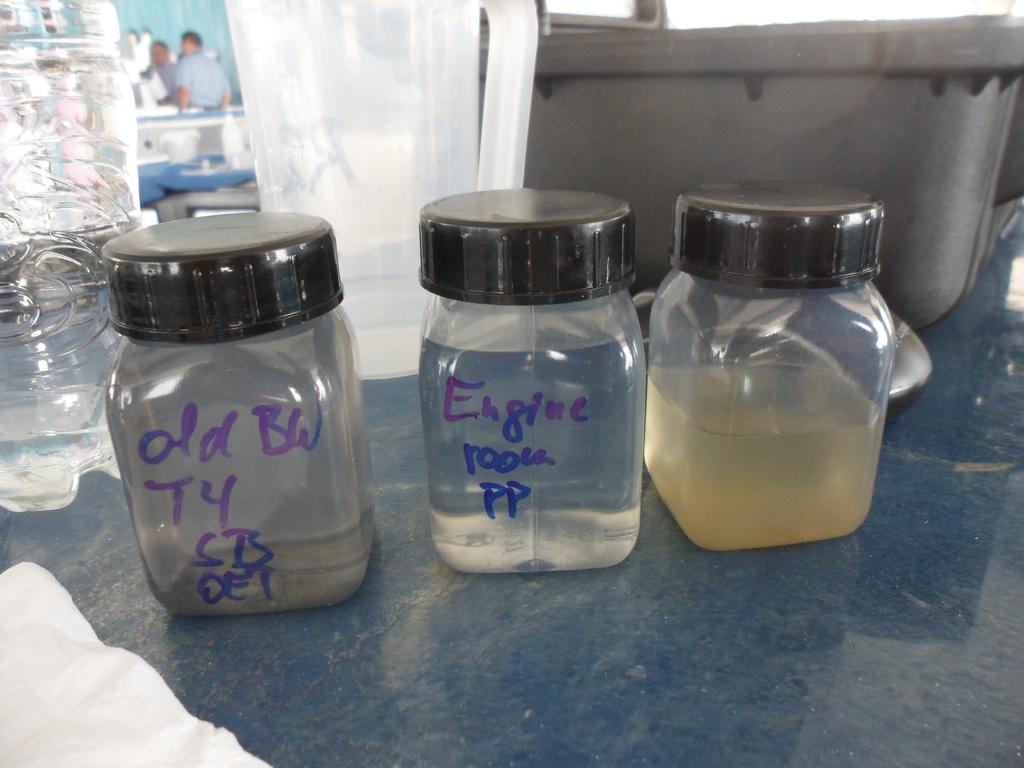What room is the middle bottle from?
Ensure brevity in your answer.  Engine room. 